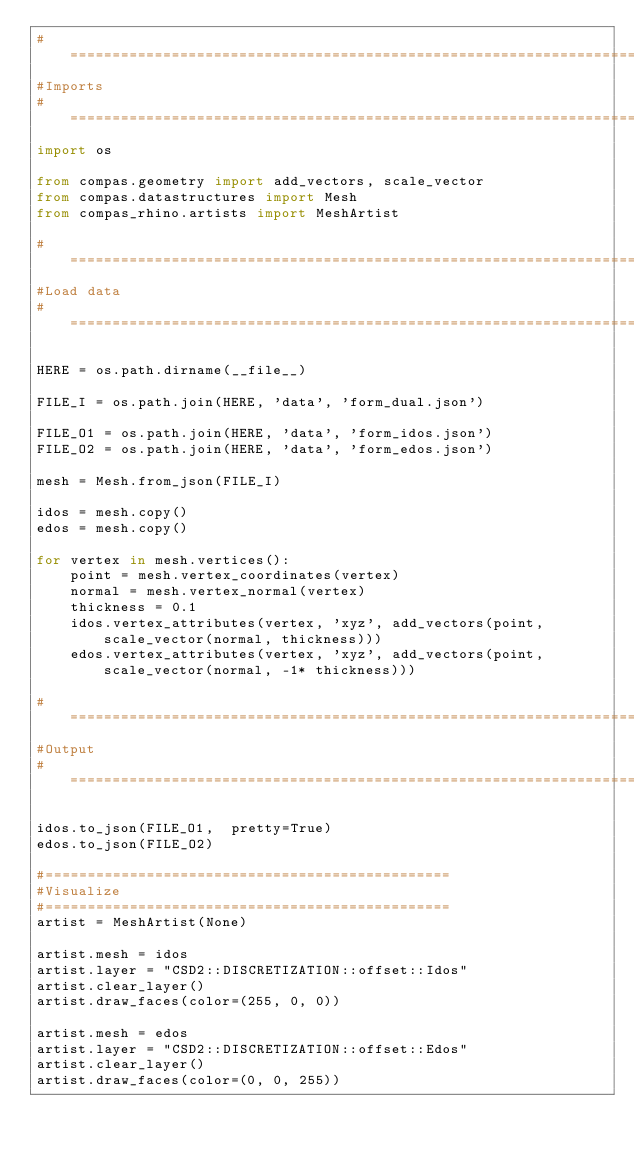Convert code to text. <code><loc_0><loc_0><loc_500><loc_500><_Python_># ==============================================================================
#Imports
# ==============================================================================
import os

from compas.geometry import add_vectors, scale_vector
from compas.datastructures import Mesh
from compas_rhino.artists import MeshArtist

# ==============================================================================
#Load data
# ==============================================================================

HERE = os.path.dirname(__file__)

FILE_I = os.path.join(HERE, 'data', 'form_dual.json')

FILE_O1 = os.path.join(HERE, 'data', 'form_idos.json')
FILE_O2 = os.path.join(HERE, 'data', 'form_edos.json')

mesh = Mesh.from_json(FILE_I)

idos = mesh.copy()
edos = mesh.copy()

for vertex in mesh.vertices():
    point = mesh.vertex_coordinates(vertex)
    normal = mesh.vertex_normal(vertex)
    thickness = 0.1
    idos.vertex_attributes(vertex, 'xyz', add_vectors(point, scale_vector(normal, thickness)))
    edos.vertex_attributes(vertex, 'xyz', add_vectors(point, scale_vector(normal, -1* thickness)))

# ==============================================================================
#Output
# ==============================================================================

idos.to_json(FILE_O1,  pretty=True)
edos.to_json(FILE_O2)

#================================================
#Visualize
#================================================
artist = MeshArtist(None)

artist.mesh = idos
artist.layer = "CSD2::DISCRETIZATION::offset::Idos"
artist.clear_layer()
artist.draw_faces(color=(255, 0, 0))

artist.mesh = edos
artist.layer = "CSD2::DISCRETIZATION::offset::Edos"
artist.clear_layer()
artist.draw_faces(color=(0, 0, 255))
</code> 